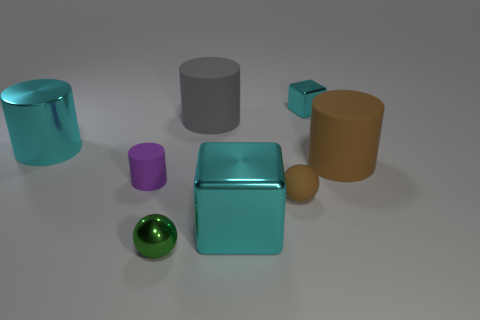What material is the object that is the same color as the rubber ball?
Give a very brief answer. Rubber. How many small rubber objects are on the right side of the tiny green shiny object and on the left side of the small green metal ball?
Keep it short and to the point. 0. What is the material of the brown object left of the shiny cube behind the small purple object?
Ensure brevity in your answer.  Rubber. Is there a tiny thing that has the same material as the small brown sphere?
Your answer should be compact. Yes. There is a brown cylinder that is the same size as the gray rubber thing; what is it made of?
Your response must be concise. Rubber. What is the size of the cyan cube in front of the matte cylinder that is to the right of the cyan metallic block in front of the tiny cyan cube?
Your answer should be compact. Large. Are there any things in front of the tiny sphere that is right of the big cyan block?
Offer a terse response. Yes. Does the small purple object have the same shape as the brown matte thing that is behind the tiny brown object?
Provide a succinct answer. Yes. There is a large rubber cylinder that is to the right of the gray rubber object; what is its color?
Provide a succinct answer. Brown. There is a rubber cylinder that is behind the brown matte thing that is behind the tiny purple cylinder; what is its size?
Offer a terse response. Large. 